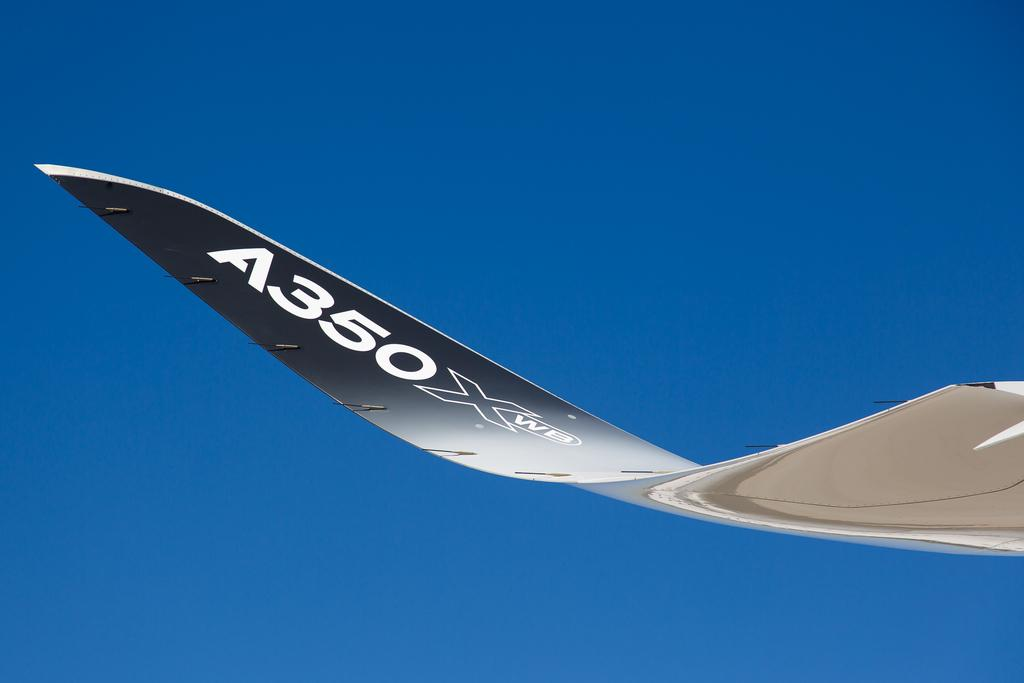Provide a one-sentence caption for the provided image. A wing of an airplane has the identifier A350 XWB on it. 